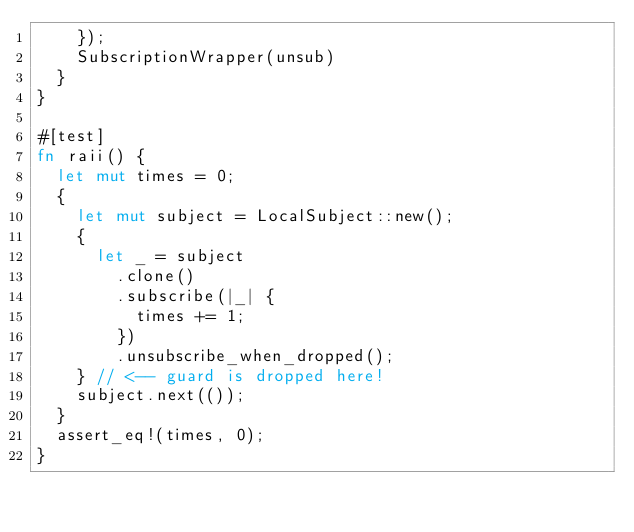<code> <loc_0><loc_0><loc_500><loc_500><_Rust_>    });
    SubscriptionWrapper(unsub)
  }
}

#[test]
fn raii() {
  let mut times = 0;
  {
    let mut subject = LocalSubject::new();
    {
      let _ = subject
        .clone()
        .subscribe(|_| {
          times += 1;
        })
        .unsubscribe_when_dropped();
    } // <-- guard is dropped here!
    subject.next(());
  }
  assert_eq!(times, 0);
}
</code> 